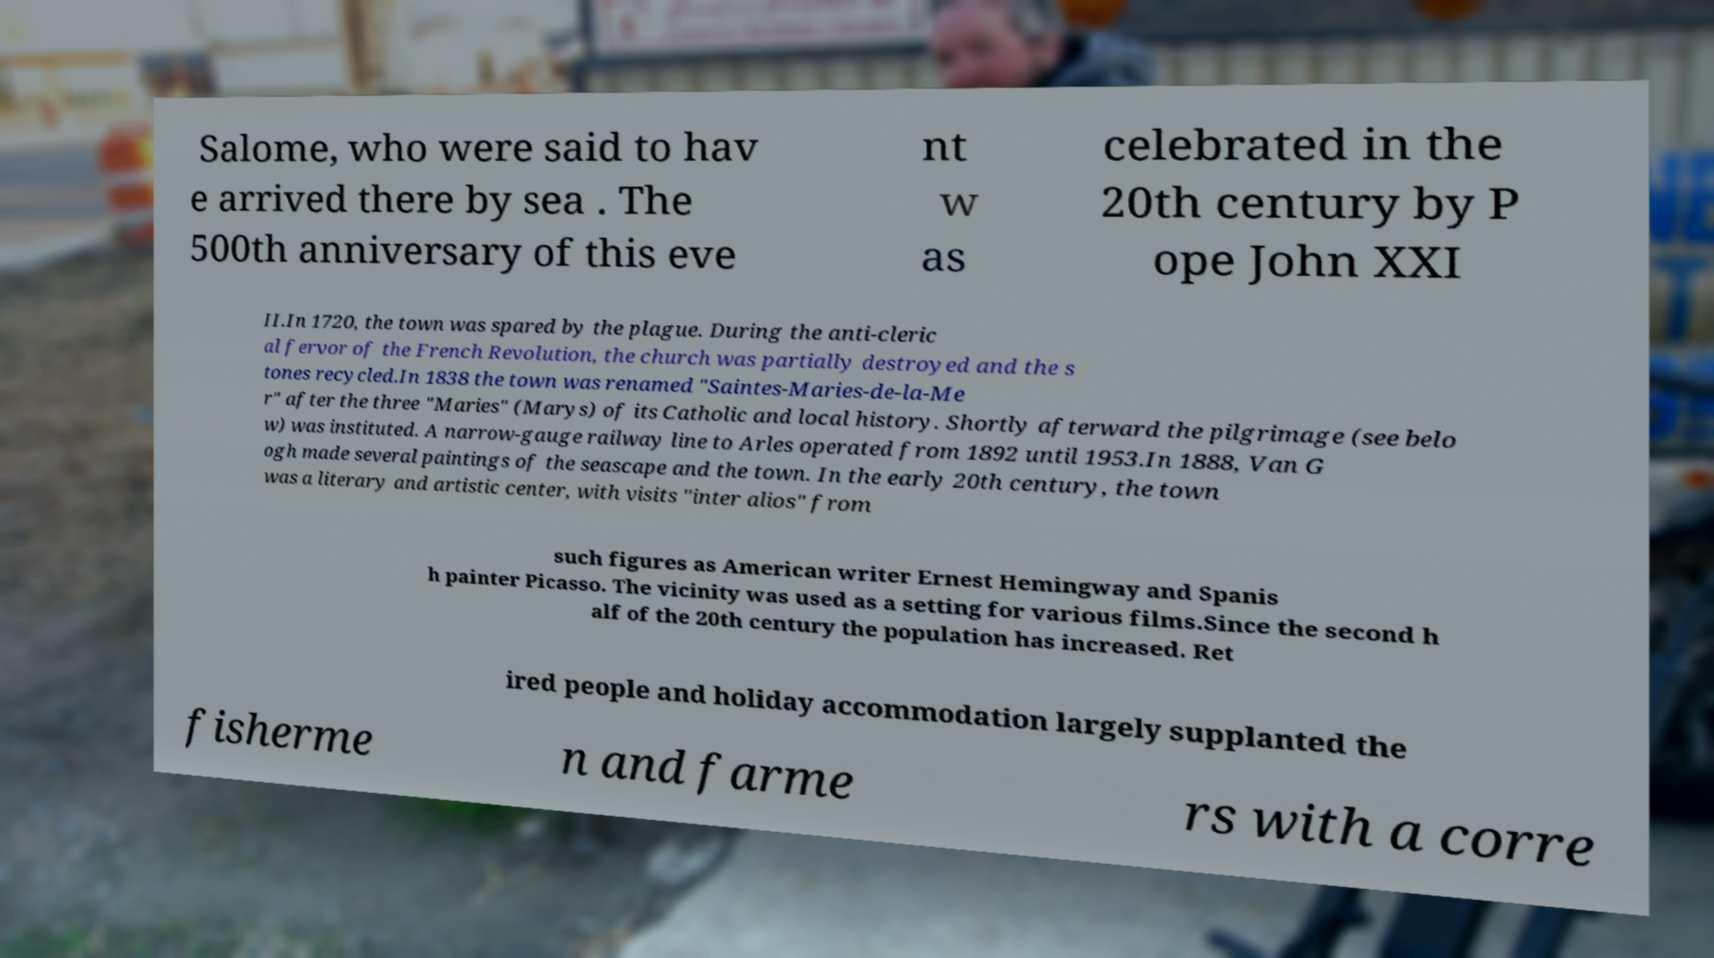Please identify and transcribe the text found in this image. Salome, who were said to hav e arrived there by sea . The 500th anniversary of this eve nt w as celebrated in the 20th century by P ope John XXI II.In 1720, the town was spared by the plague. During the anti-cleric al fervor of the French Revolution, the church was partially destroyed and the s tones recycled.In 1838 the town was renamed "Saintes-Maries-de-la-Me r" after the three "Maries" (Marys) of its Catholic and local history. Shortly afterward the pilgrimage (see belo w) was instituted. A narrow-gauge railway line to Arles operated from 1892 until 1953.In 1888, Van G ogh made several paintings of the seascape and the town. In the early 20th century, the town was a literary and artistic center, with visits "inter alios" from such figures as American writer Ernest Hemingway and Spanis h painter Picasso. The vicinity was used as a setting for various films.Since the second h alf of the 20th century the population has increased. Ret ired people and holiday accommodation largely supplanted the fisherme n and farme rs with a corre 